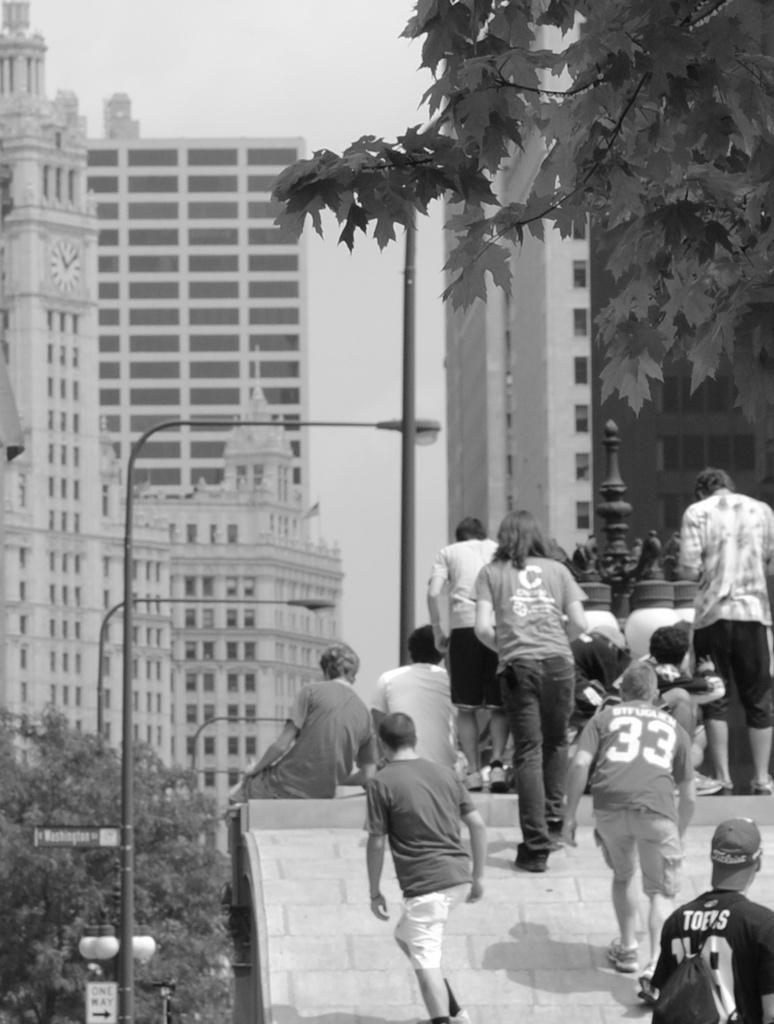<image>
Share a concise interpretation of the image provided. people are walking including a man wearing a number 33 shirt 